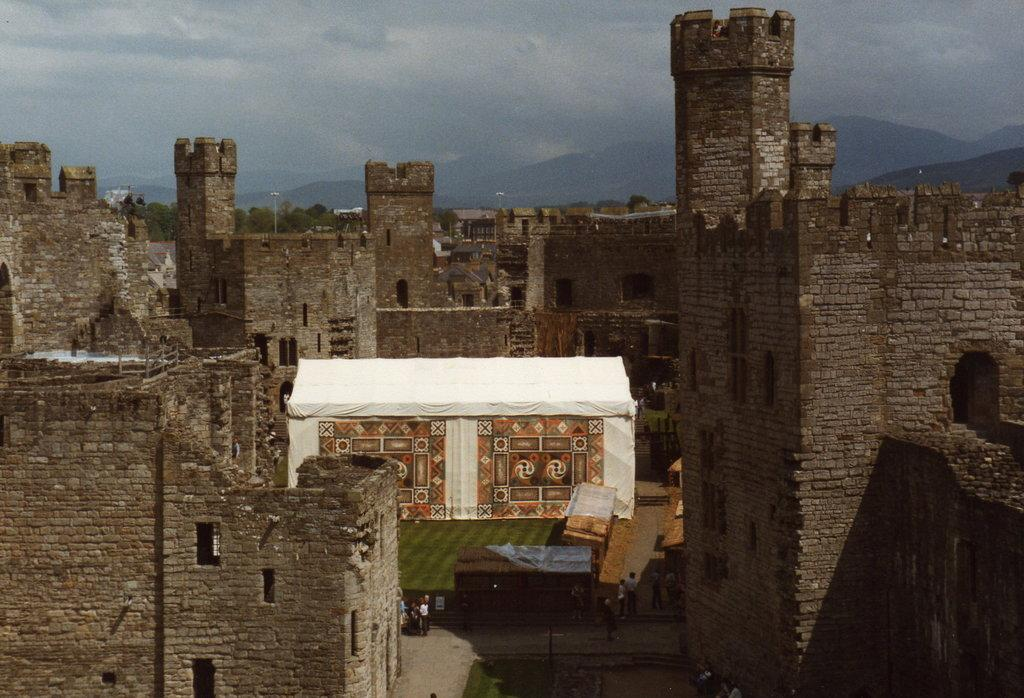What type of structures can be seen in the image? There are buildings in the image. Are there any living beings present in the image? Yes, there are people in the image. What type of temporary shelter is visible in the image? There is a tent in the image. What natural feature can be seen in the background of the image? There are mountains in the image. What is visible above the buildings and mountains in the image? The sky is visible in the image. Can you tell me how many shoes are placed on top of the tent in the image? There are no shoes present in the image; it only features buildings, people, a tent, mountains, and the sky. What type of wind can be seen blowing through the image? There is no wind visible in the image, and the term "zephyr" is not relevant to the content of the image. 